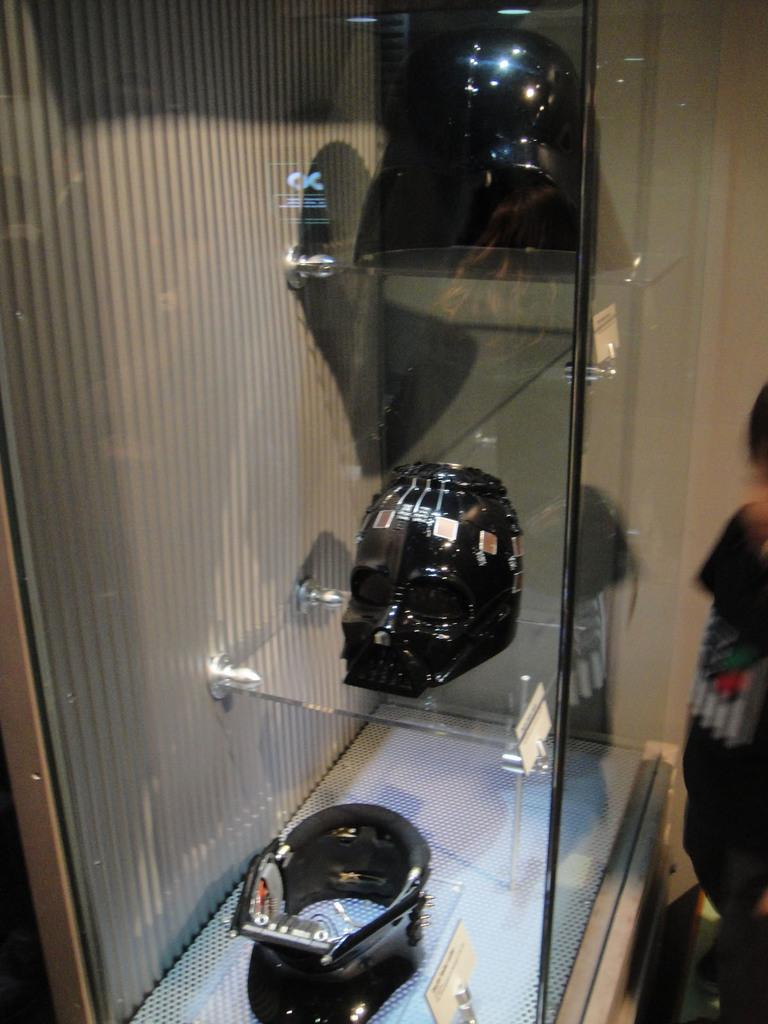What is the main object in the center of the image? There is a rack in the center of the image. What is on the rack? The rack contains masks. Can you describe the person on the right side of the image? There is a small boy on the right side of the image. How does the small boy use the cork to make a wish in the image? There is no cork present in the image, and the small boy is not making a wish. 